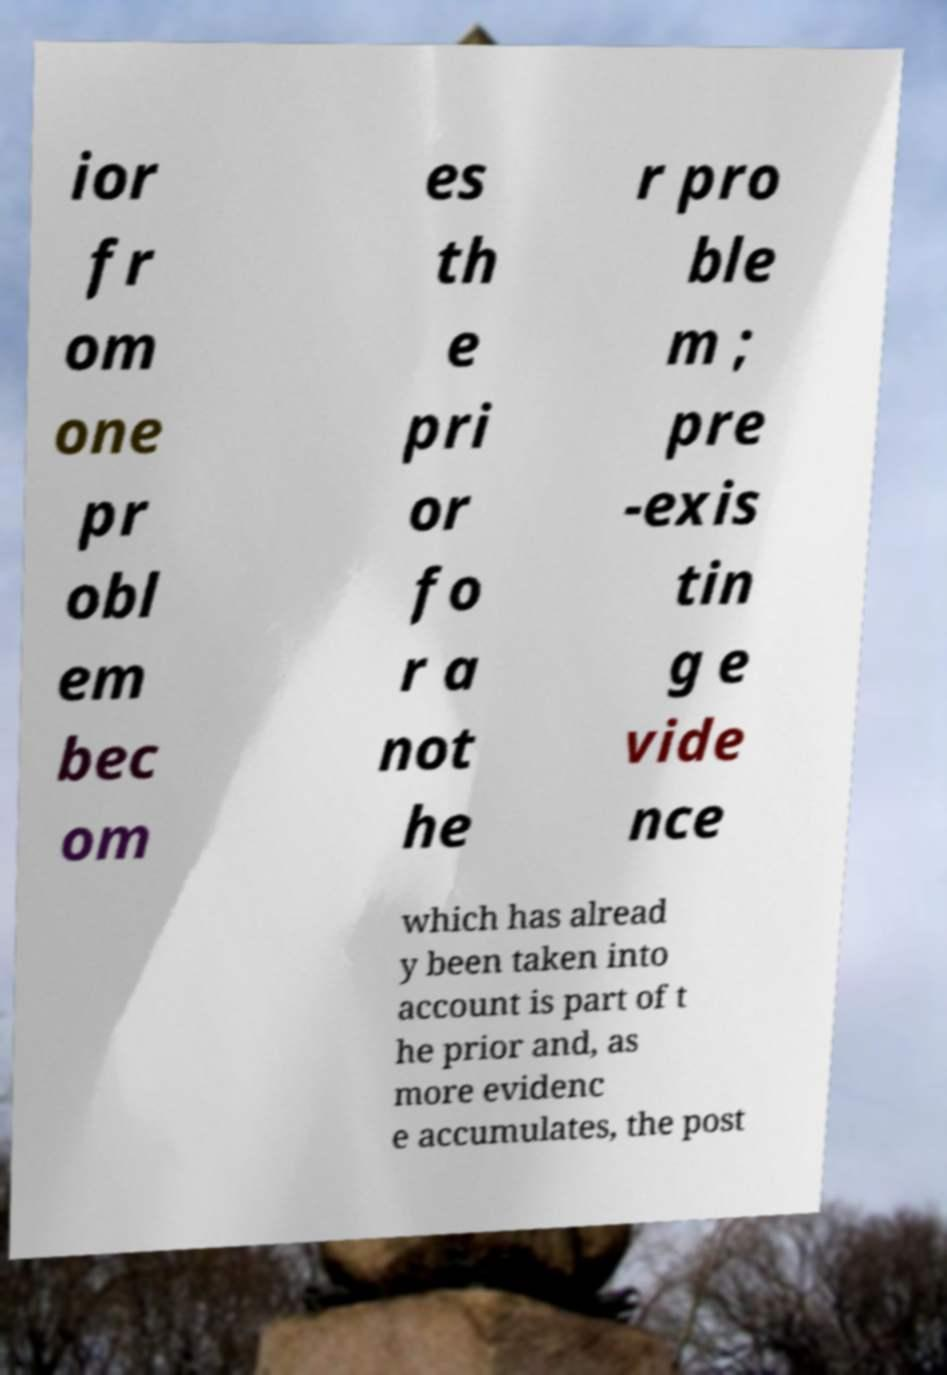Please identify and transcribe the text found in this image. ior fr om one pr obl em bec om es th e pri or fo r a not he r pro ble m ; pre -exis tin g e vide nce which has alread y been taken into account is part of t he prior and, as more evidenc e accumulates, the post 